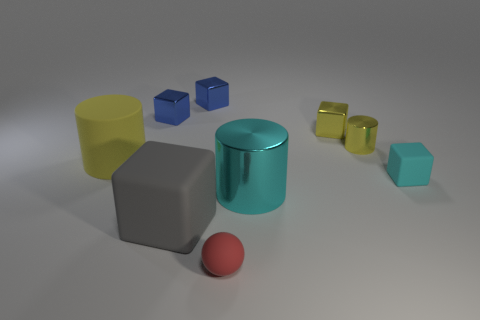What is the size of the rubber cylinder?
Your answer should be very brief. Large. There is a small matte object behind the thing in front of the rubber block on the left side of the matte ball; what color is it?
Provide a succinct answer. Cyan. Is the color of the matte cube left of the red ball the same as the tiny rubber ball?
Your answer should be very brief. No. How many cubes are in front of the tiny shiny cylinder and behind the cyan cylinder?
Keep it short and to the point. 1. There is another yellow metal object that is the same shape as the big yellow object; what is its size?
Ensure brevity in your answer.  Small. What number of gray matte cubes are behind the tiny rubber thing that is in front of the tiny block that is in front of the large yellow cylinder?
Provide a succinct answer. 1. There is a large cylinder right of the big cylinder on the left side of the small matte sphere; what color is it?
Offer a terse response. Cyan. How many other things are the same material as the large yellow cylinder?
Give a very brief answer. 3. There is a matte block that is to the left of the tiny cyan rubber object; what number of big gray cubes are in front of it?
Provide a succinct answer. 0. Is there anything else that has the same shape as the large cyan object?
Provide a short and direct response. Yes. 